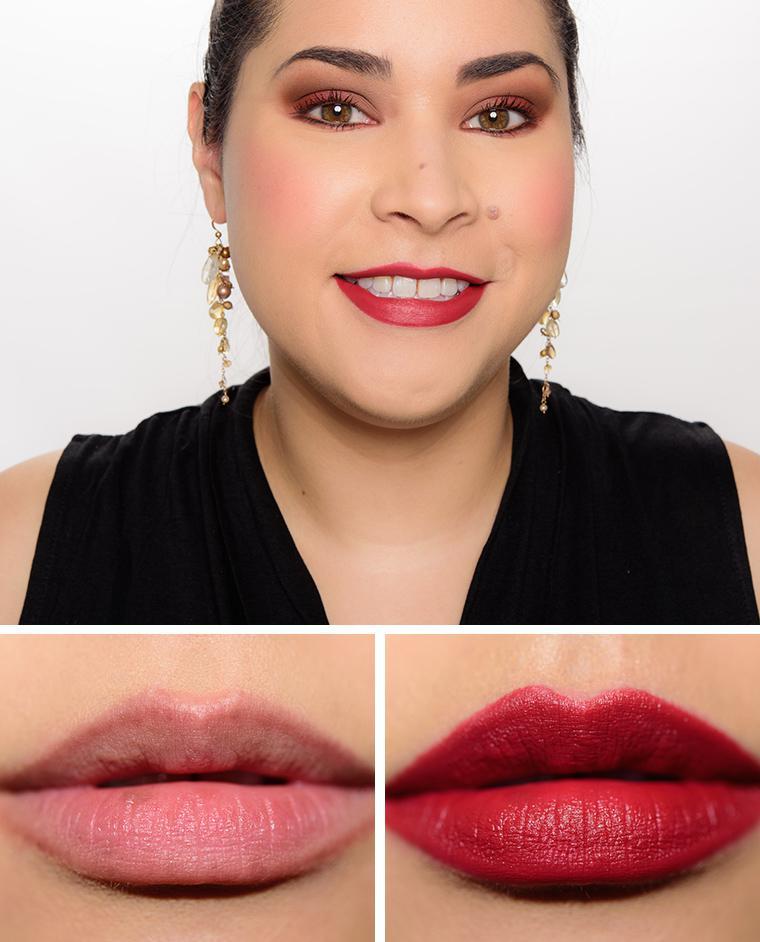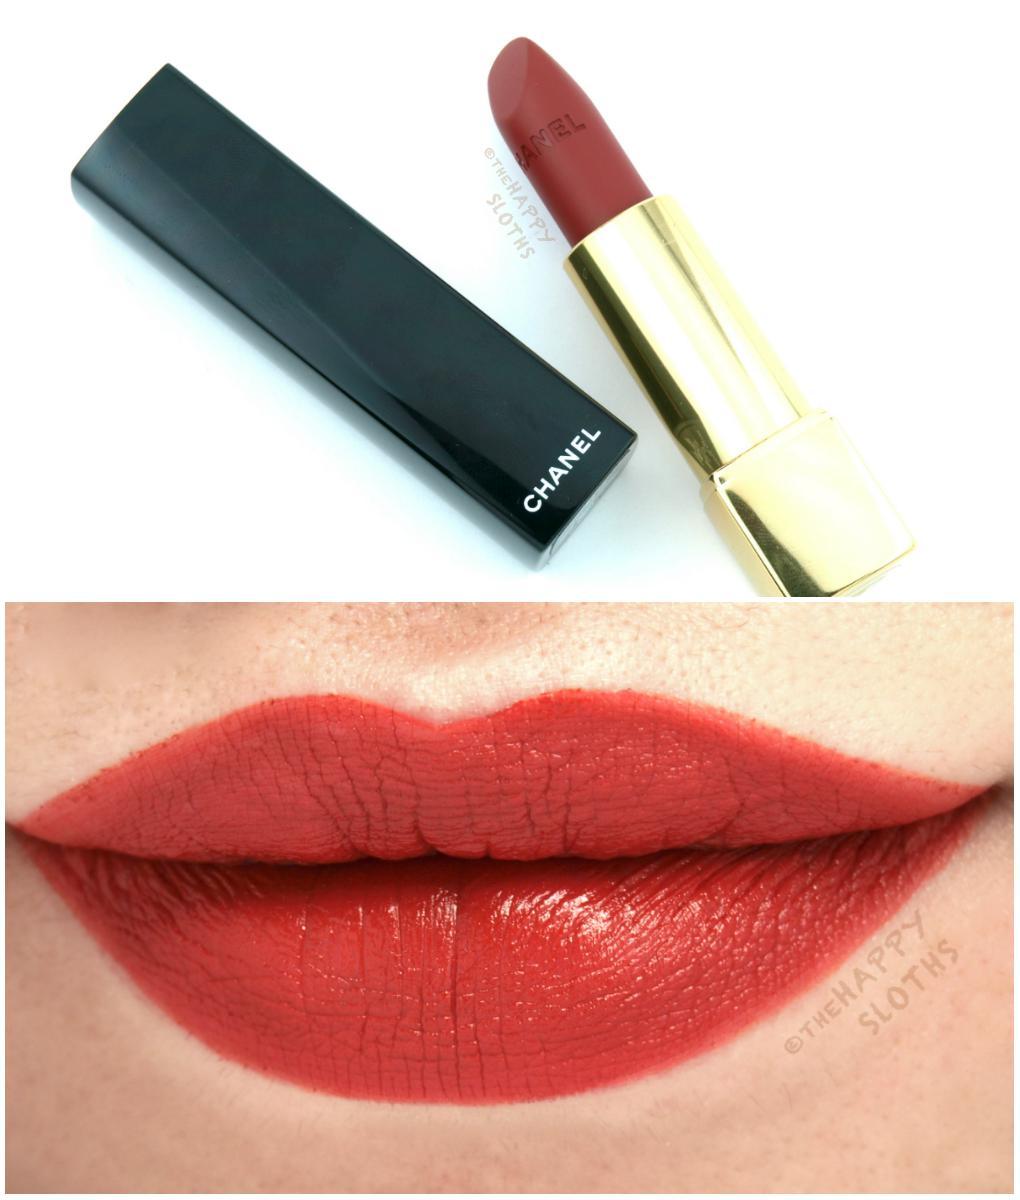The first image is the image on the left, the second image is the image on the right. Examine the images to the left and right. Is the description "A single pair of lips is wearing lipstick in each of the images." accurate? Answer yes or no. No. The first image is the image on the left, the second image is the image on the right. Assess this claim about the two images: "One image includes a lip makeup item and at least one pair of tinted lips, and the other image contains at least one pair of tinted lips but no lip makeup item.". Correct or not? Answer yes or no. Yes. 